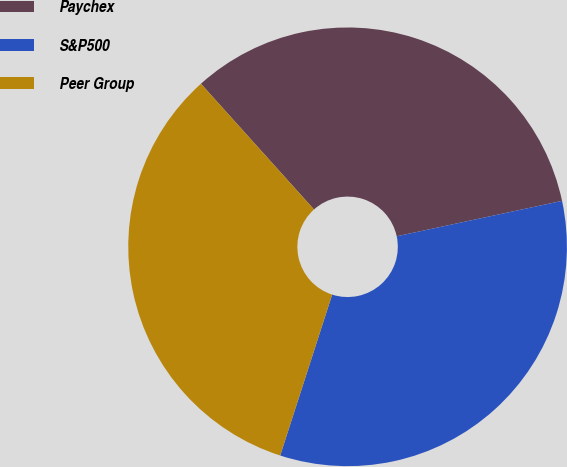<chart> <loc_0><loc_0><loc_500><loc_500><pie_chart><fcel>Paychex<fcel>S&P500<fcel>Peer Group<nl><fcel>33.3%<fcel>33.33%<fcel>33.37%<nl></chart> 